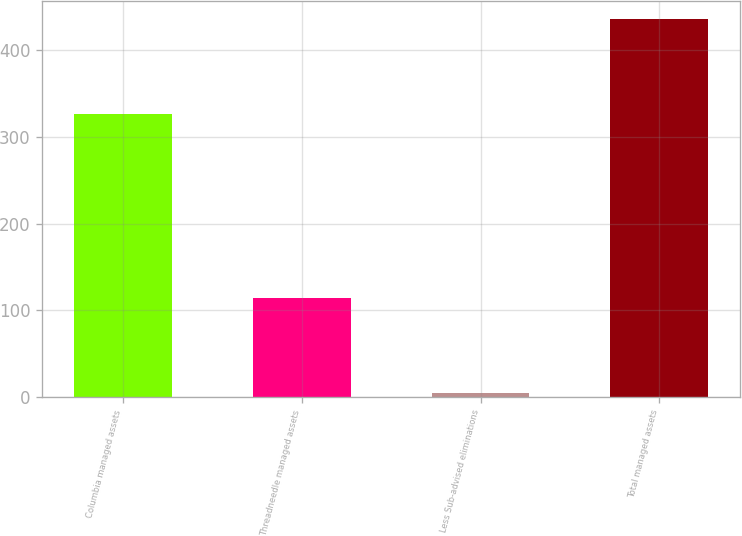Convert chart. <chart><loc_0><loc_0><loc_500><loc_500><bar_chart><fcel>Columbia managed assets<fcel>Threadneedle managed assets<fcel>Less Sub-advised eliminations<fcel>Total managed assets<nl><fcel>326.1<fcel>113.6<fcel>4.2<fcel>435.5<nl></chart> 